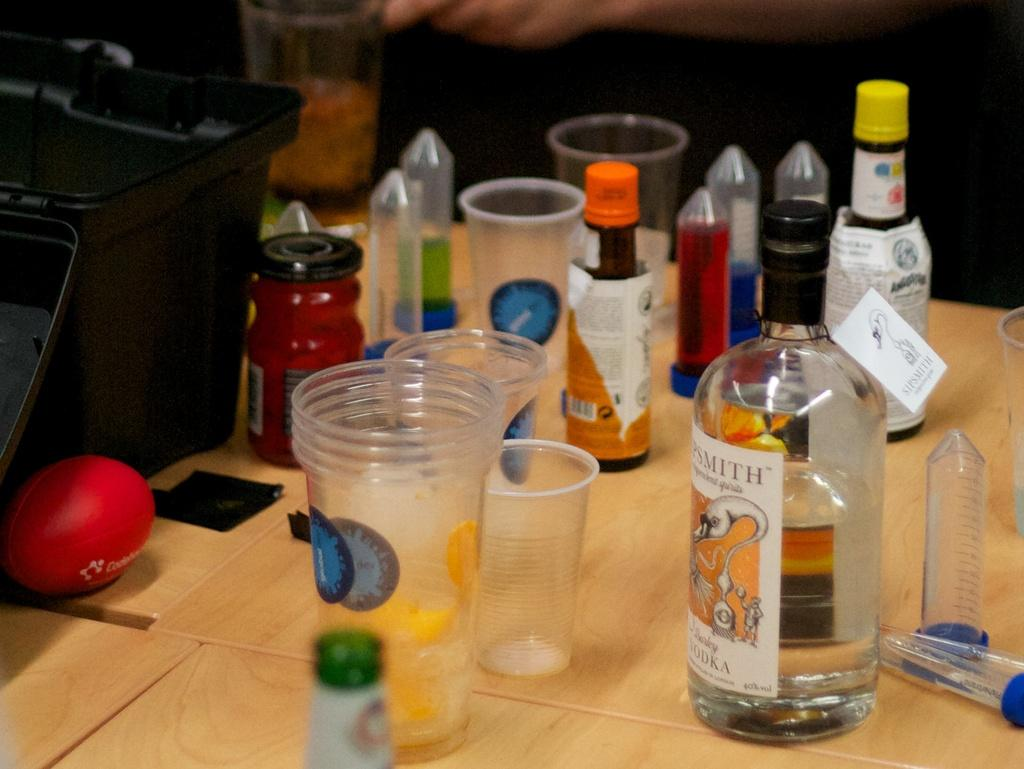What type of furniture is present in the image? There is a table in the image. What is placed on the table? A glass, an alcohol bottle, a wine bottle, a jam bottle, a red ball, and a black bag are placed on the table. How many bottles are visible on the table? There are three bottles on the table: an alcohol bottle, a wine bottle, and a jam bottle. What type of fang can be seen on the table in the image? There is no fang present on the table in the image. What type of quartz is visible on the table in the image? There is no quartz present on the table in the image. 